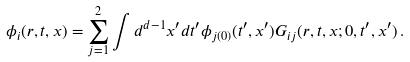<formula> <loc_0><loc_0><loc_500><loc_500>\phi _ { i } ( r , t , { x } ) = \sum _ { j = 1 } ^ { 2 } \int d ^ { d - 1 } { x } ^ { \prime } d t ^ { \prime } \phi _ { j ( 0 ) } ( t ^ { \prime } , { x } ^ { \prime } ) G _ { i j } ( r , t , { x } ; 0 , t ^ { \prime } , { x } ^ { \prime } ) \, .</formula> 